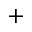<formula> <loc_0><loc_0><loc_500><loc_500>^ { + }</formula> 